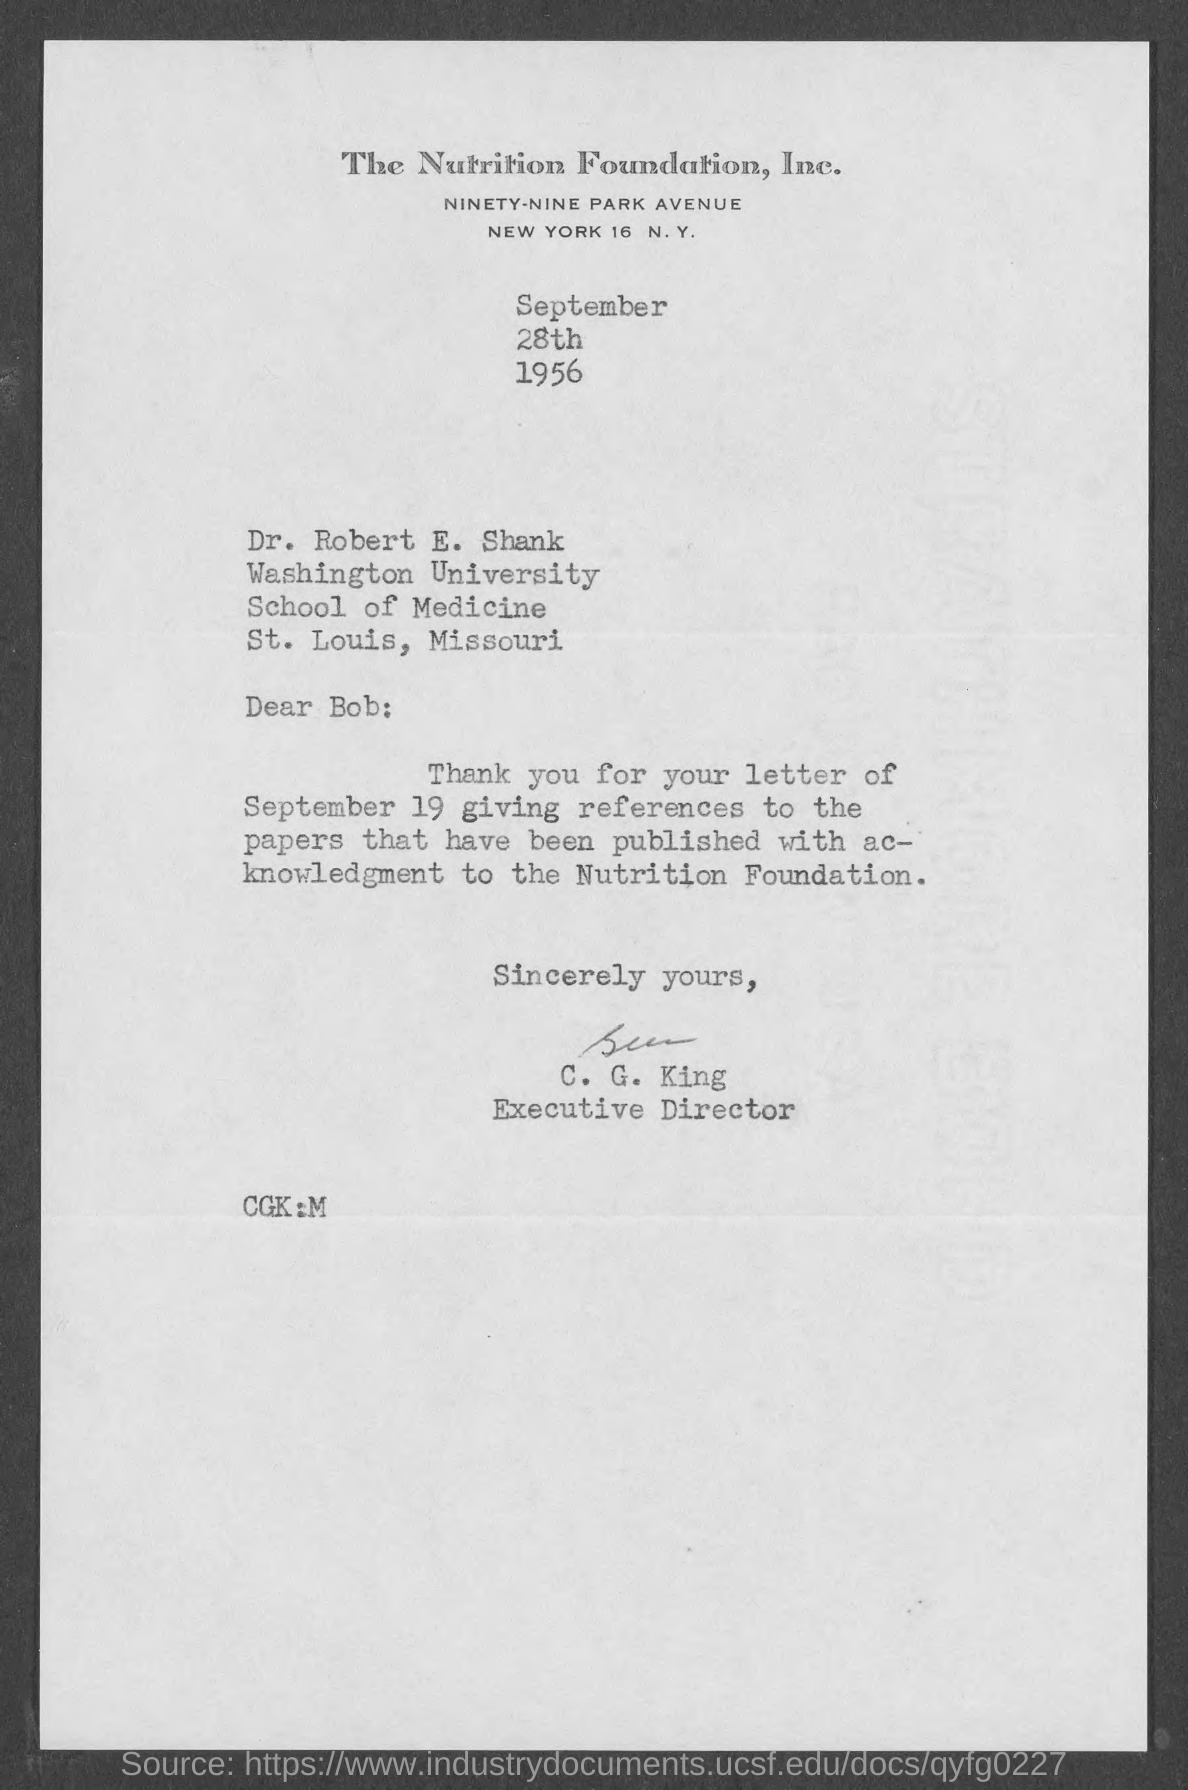Specify some key components in this picture. The date on the document is September 28th, 1956. The letter is addressed to Dr. Robert E. Shank. The letter is from C. G. King. 